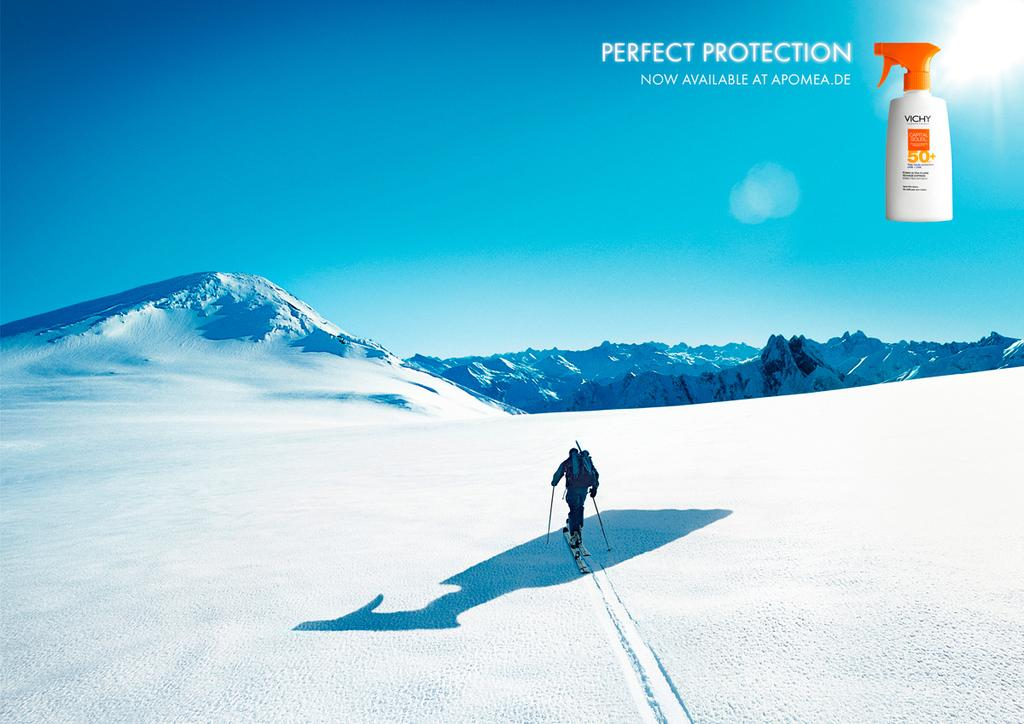Provide a one-sentence caption for the provided image. An advertisement for sunscreen by Vichy features a skiier on a snowy mountain. 